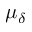<formula> <loc_0><loc_0><loc_500><loc_500>\mu _ { \delta }</formula> 